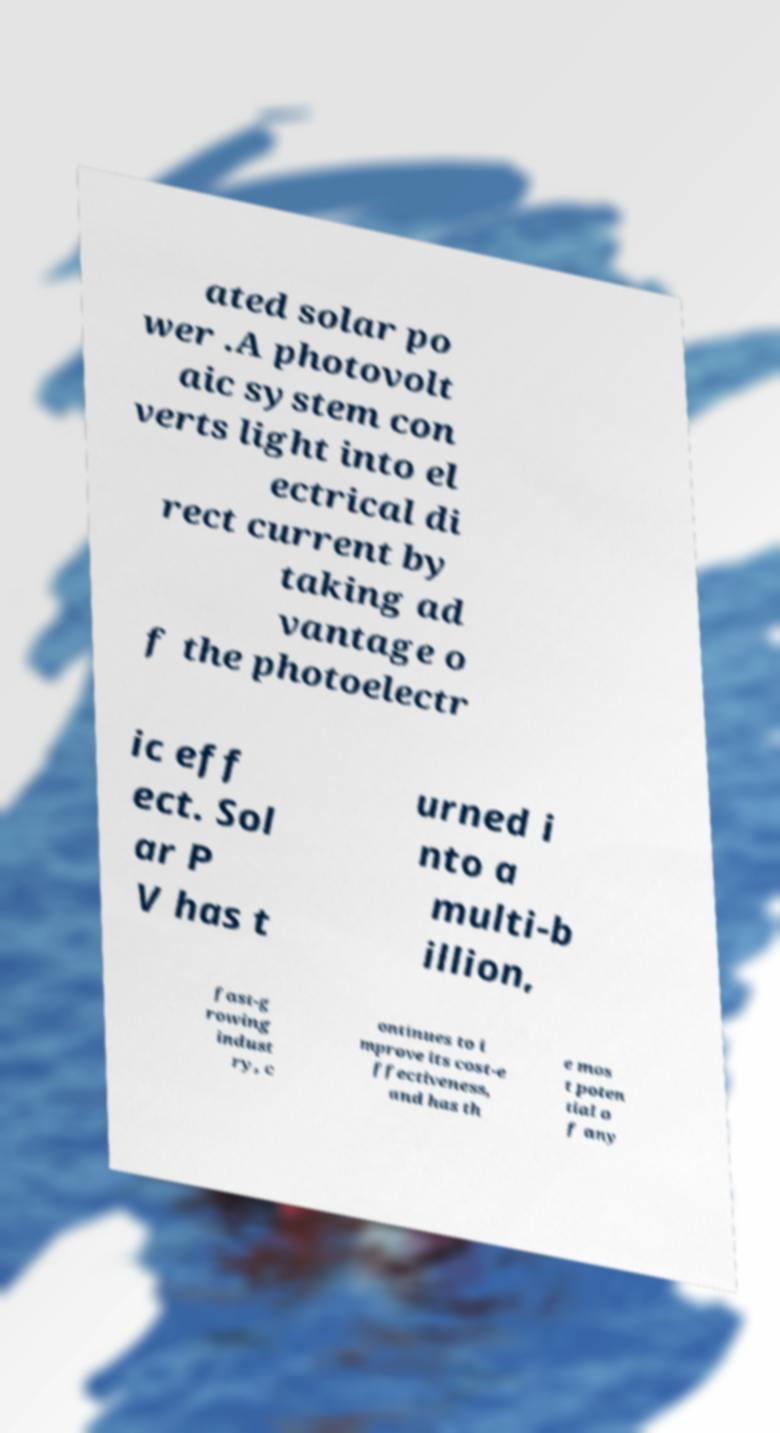Could you extract and type out the text from this image? ated solar po wer .A photovolt aic system con verts light into el ectrical di rect current by taking ad vantage o f the photoelectr ic eff ect. Sol ar P V has t urned i nto a multi-b illion, fast-g rowing indust ry, c ontinues to i mprove its cost-e ffectiveness, and has th e mos t poten tial o f any 